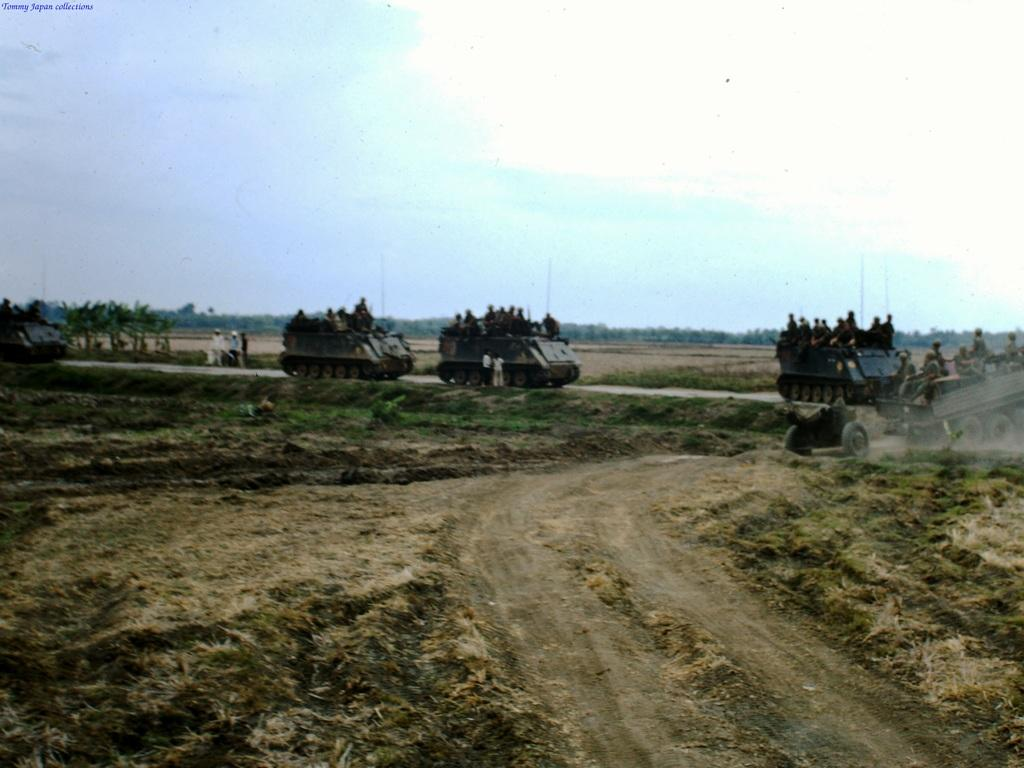What is the main subject in the center of the image? There are war tanks and persons in the center of the image. What type of terrain is visible at the bottom of the image? There is grass at the bottom of the image. What can be seen in the background of the image? There are poles, trees, sky, and clouds visible in the background of the image. What type of alley can be seen in the image? There is no alley present in the image. How does the kitten express its hate towards the war tanks in the image? There is no kitten or expression of hate present in the image. 